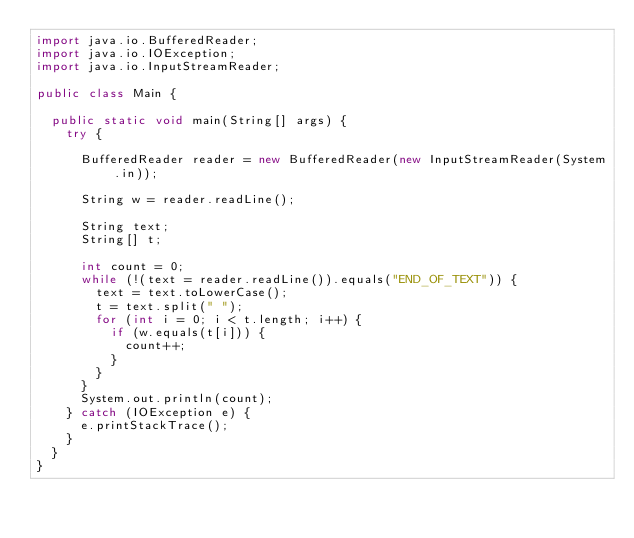<code> <loc_0><loc_0><loc_500><loc_500><_Java_>import java.io.BufferedReader;
import java.io.IOException;
import java.io.InputStreamReader;

public class Main {
	
	public static void main(String[] args) {
		try {

			BufferedReader reader = new BufferedReader(new InputStreamReader(System.in));
			
			String w = reader.readLine();
			
			String text;
			String[] t;
			
			int count = 0;
			while (!(text = reader.readLine()).equals("END_OF_TEXT")) {
				text = text.toLowerCase();
				t = text.split(" ");
				for (int i = 0; i < t.length; i++) {
					if (w.equals(t[i])) {
						count++;
					}
				}
			}
			System.out.println(count);
		} catch (IOException e) {
			e.printStackTrace();
		}
	}
}</code> 